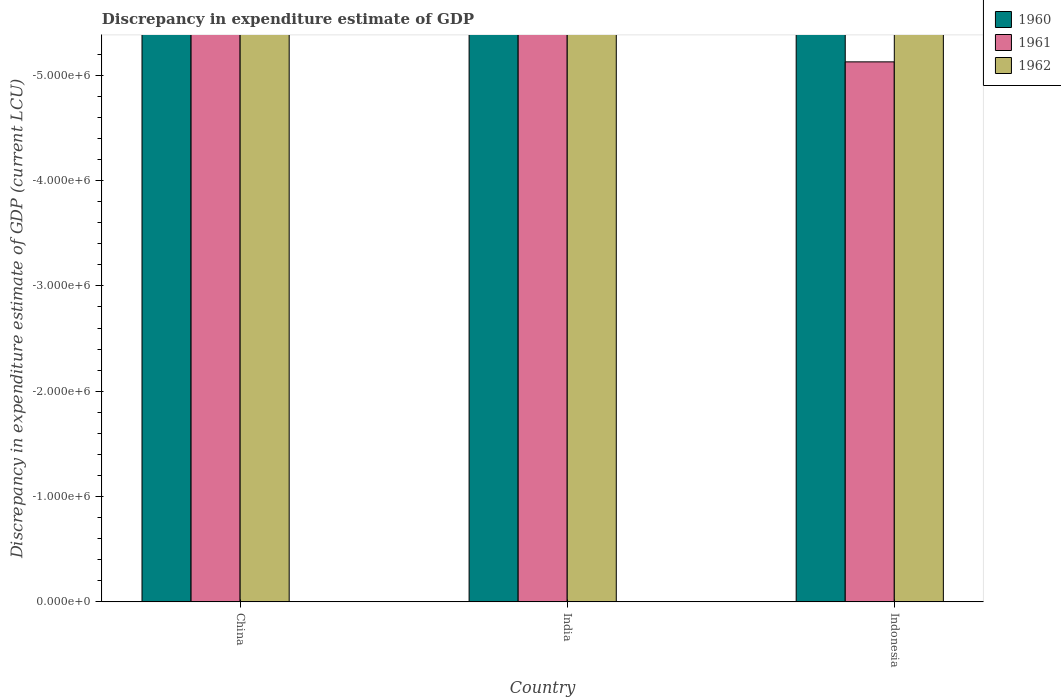Are the number of bars per tick equal to the number of legend labels?
Make the answer very short. No. Are the number of bars on each tick of the X-axis equal?
Your response must be concise. Yes. How many bars are there on the 1st tick from the left?
Your answer should be very brief. 0. How many bars are there on the 1st tick from the right?
Provide a short and direct response. 0. In how many cases, is the number of bars for a given country not equal to the number of legend labels?
Your answer should be very brief. 3. What is the total discrepancy in expenditure estimate of GDP in 1962 in the graph?
Make the answer very short. 0. What is the difference between the discrepancy in expenditure estimate of GDP in 1960 in India and the discrepancy in expenditure estimate of GDP in 1961 in China?
Provide a succinct answer. 0. In how many countries, is the discrepancy in expenditure estimate of GDP in 1961 greater than -4800000 LCU?
Provide a short and direct response. 0. How many bars are there?
Offer a terse response. 0. Are all the bars in the graph horizontal?
Give a very brief answer. No. Does the graph contain any zero values?
Make the answer very short. Yes. Does the graph contain grids?
Keep it short and to the point. No. What is the title of the graph?
Your response must be concise. Discrepancy in expenditure estimate of GDP. Does "2014" appear as one of the legend labels in the graph?
Make the answer very short. No. What is the label or title of the X-axis?
Your answer should be compact. Country. What is the label or title of the Y-axis?
Offer a terse response. Discrepancy in expenditure estimate of GDP (current LCU). What is the Discrepancy in expenditure estimate of GDP (current LCU) of 1960 in China?
Your answer should be compact. 0. What is the Discrepancy in expenditure estimate of GDP (current LCU) of 1962 in China?
Provide a succinct answer. 0. What is the Discrepancy in expenditure estimate of GDP (current LCU) of 1960 in India?
Your answer should be very brief. 0. What is the Discrepancy in expenditure estimate of GDP (current LCU) in 1960 in Indonesia?
Keep it short and to the point. 0. What is the Discrepancy in expenditure estimate of GDP (current LCU) of 1962 in Indonesia?
Your answer should be compact. 0. What is the total Discrepancy in expenditure estimate of GDP (current LCU) in 1960 in the graph?
Your answer should be compact. 0. What is the total Discrepancy in expenditure estimate of GDP (current LCU) in 1961 in the graph?
Make the answer very short. 0. What is the average Discrepancy in expenditure estimate of GDP (current LCU) of 1961 per country?
Provide a succinct answer. 0. What is the average Discrepancy in expenditure estimate of GDP (current LCU) in 1962 per country?
Your answer should be very brief. 0. 